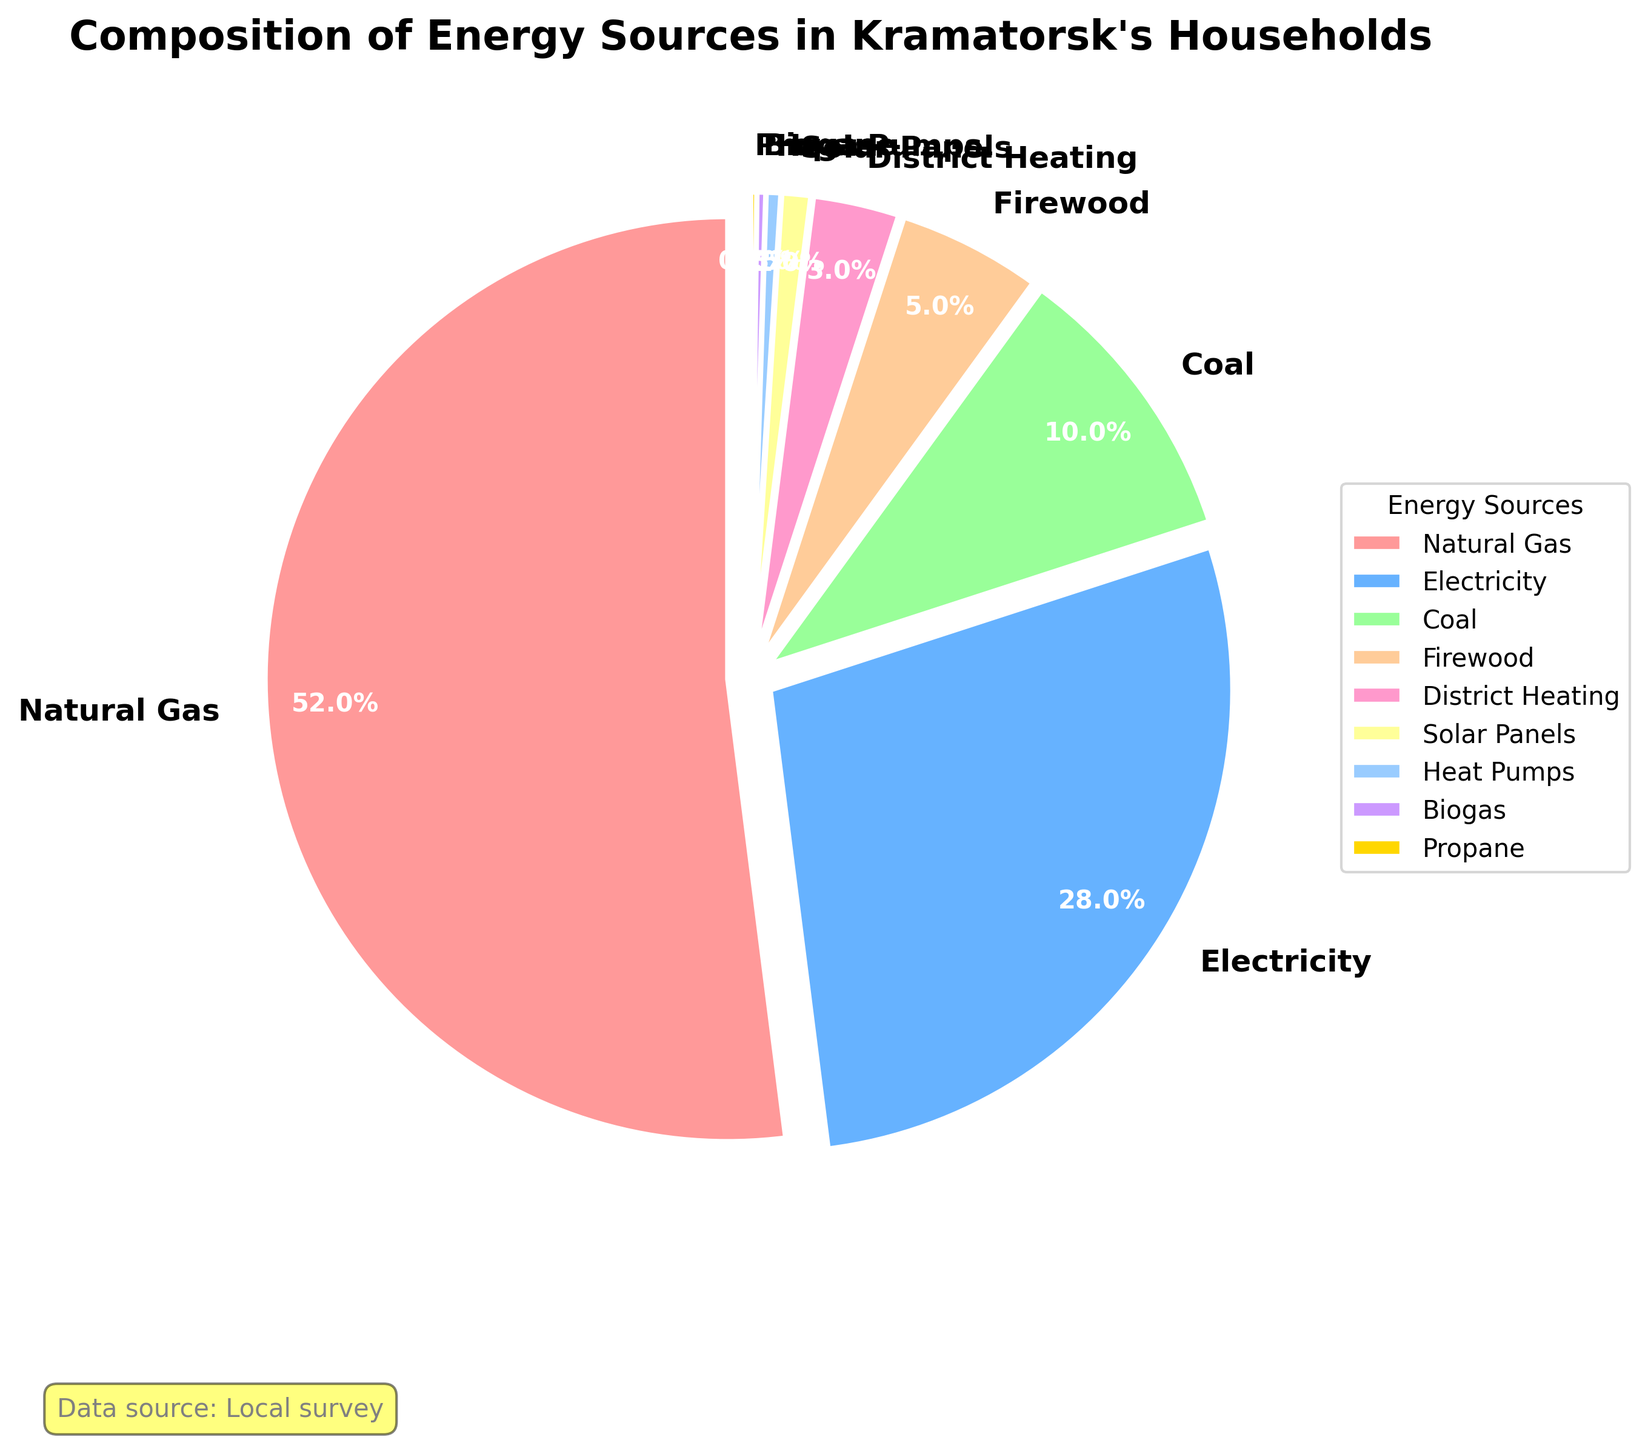Which energy source is used the most in Kramatorsk's households? The largest wedge in the pie chart represents Natural Gas, indicating it is used the most among the energy sources.
Answer: Natural Gas What is the combined percentage of households using Firewood and Coal? To find the combined percentage, sum the percentages of Firewood (5%) and Coal (10%). 5% + 10% = 15%.
Answer: 15% How does the use of Electricity compare to the use of Natural Gas? Electricity usage accounts for 28% while Natural Gas usage accounts for 52%, indicating that Natural Gas usage is significantly higher.
Answer: Natural Gas is higher Which energy sources make up less than 1% of the total distribution? The pie chart indicates that Solar Panels (1%), Heat Pumps (0.5%), Biogas (0.3%), and Propane (0.2%) each make up less than 1% of the total.
Answer: Solar Panels, Heat Pumps, Biogas, Propane What is the difference in usage percentage between District Heating and Coal? The percentage for District Heating is 3% and for Coal it is 10%. The difference in usage percentage is 10% - 3% = 7%.
Answer: 7% What proportion of households use renewable energy sources compared to non-renewable sources? Renewable energy sources include Solar Panels, Heat Pumps, and Biogas. Adding their percentages: 1% + 0.5% + 0.3% = 1.8%. Summing up the remaining sources gives the non-renewable share. Then compare the two values.
Answer: Non-renewable sources are higher How many energy sources have a percentage greater than 10%? By examining the wedges, three energy sources (Natural Gas - 52%, Electricity - 28%, Coal - 10%) have a percentage greater than 10%.
Answer: 3 What color is used to represent Propane in the pie chart? The pie chart uses a specific color palette, and based on the details, Propane is represented by the last color in the list, which is yellow/golden.
Answer: Yellow/Golden What percentage of households use Heat Pumps and Biogas combined? Adding the percentage of households using Heat Pumps and Biogas gives: 0.5% + 0.3% = 0.8%.
Answer: 0.8% Is the percentage of households using natural gas over 50%? The pie chart wedge for Natural Gas indicates a percentage of 52%, which is over 50%.
Answer: Yes 